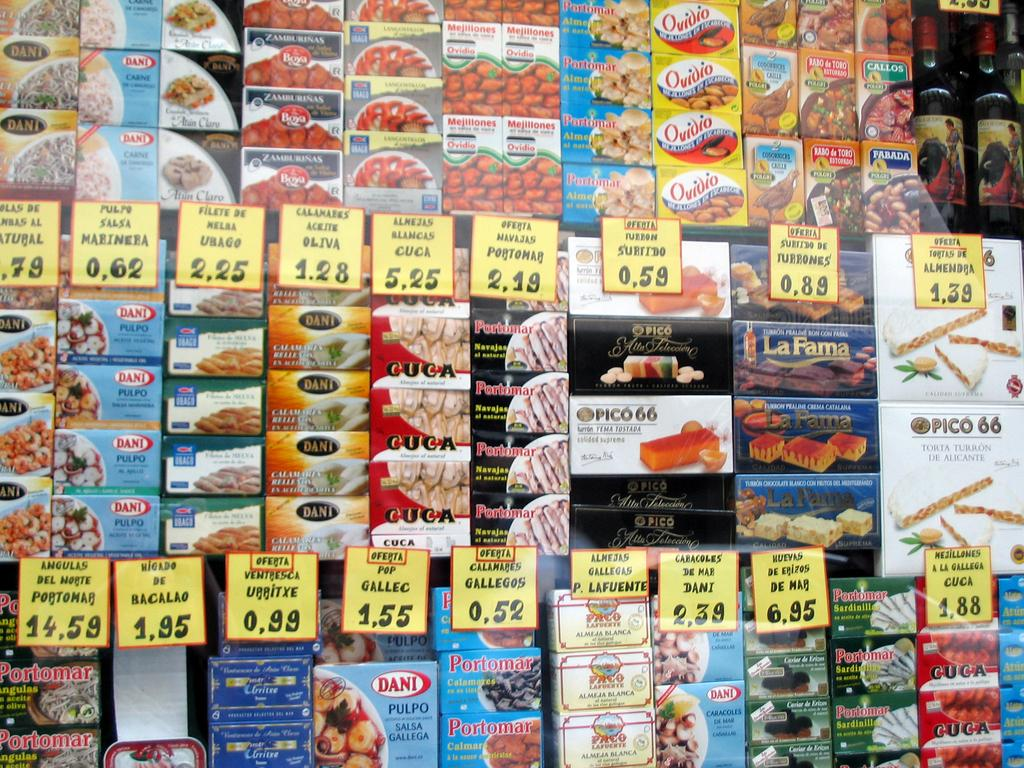<image>
Describe the image concisely. Diverse food products, including some from the Dani brand, in small boxes are organized and have yellow price tags. 